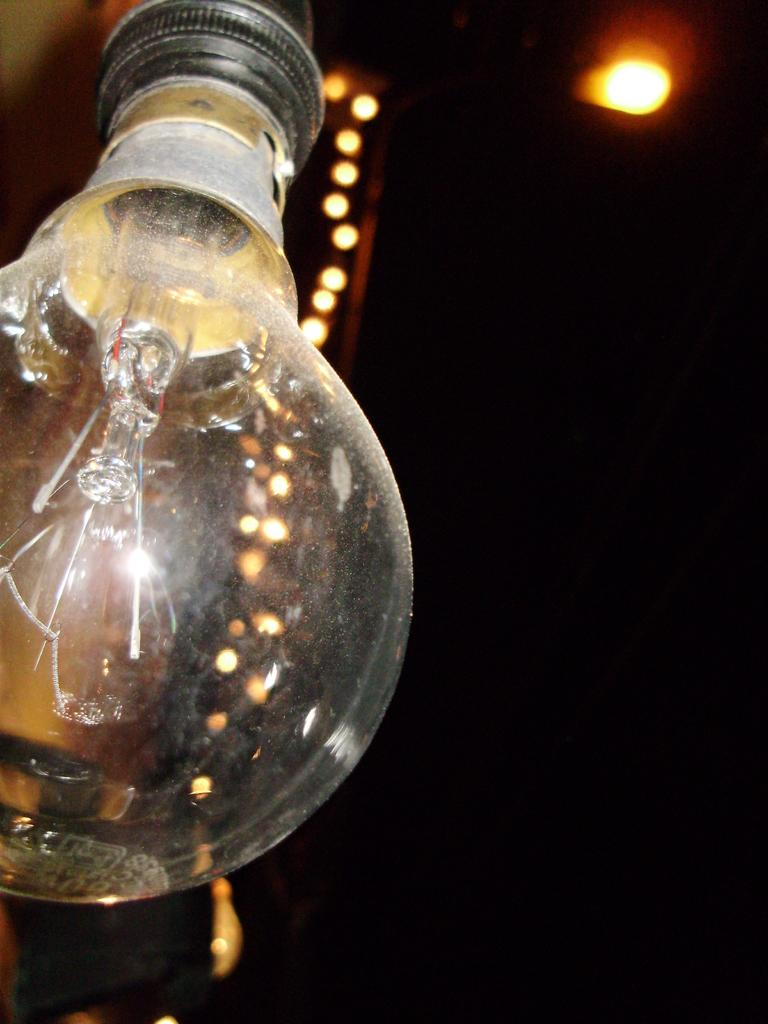What object is the main focus of the image? There is a bulb in the image. What else can be seen in the image besides the bulb? There are lights visible in the background of the image. How would you describe the lighting conditions in the image? The image appears to be slightly dark in the background. Is the bulb in the image wearing a collar? There is no collar present in the image, as the bulb is an inanimate object and not a living being. 